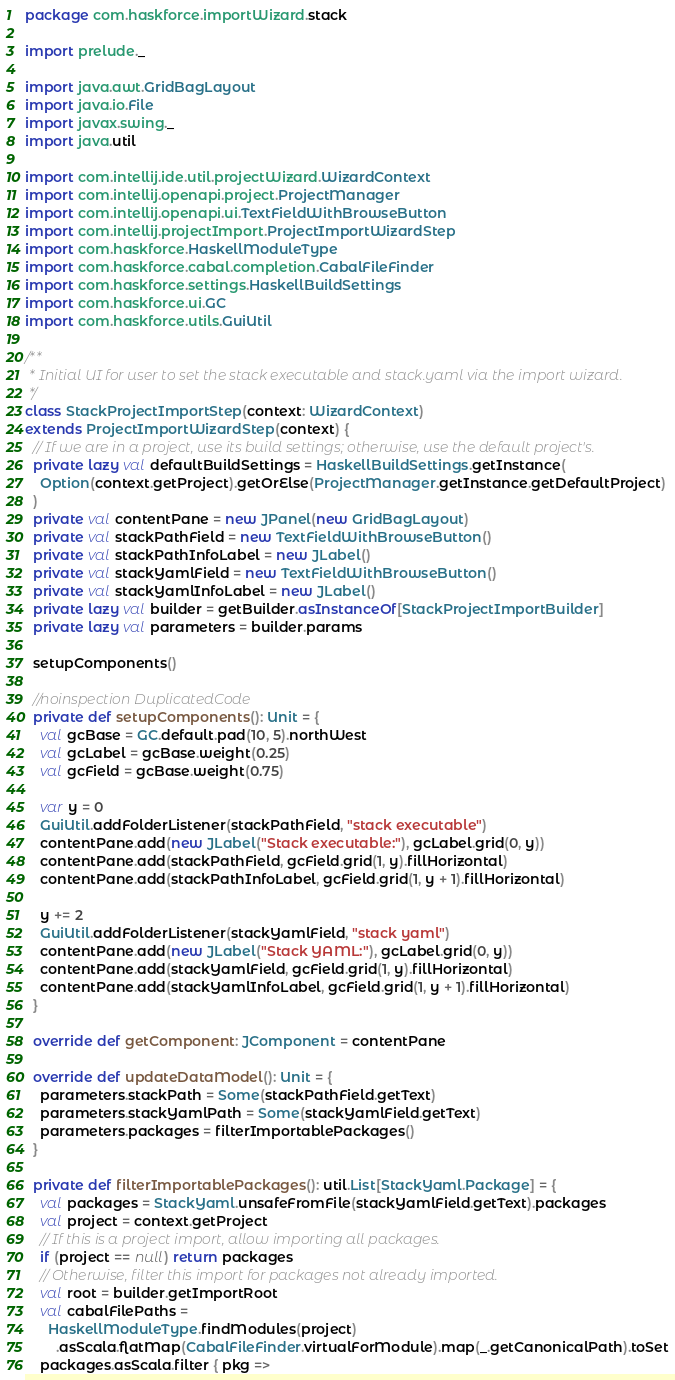<code> <loc_0><loc_0><loc_500><loc_500><_Scala_>package com.haskforce.importWizard.stack

import prelude._

import java.awt.GridBagLayout
import java.io.File
import javax.swing._
import java.util

import com.intellij.ide.util.projectWizard.WizardContext
import com.intellij.openapi.project.ProjectManager
import com.intellij.openapi.ui.TextFieldWithBrowseButton
import com.intellij.projectImport.ProjectImportWizardStep
import com.haskforce.HaskellModuleType
import com.haskforce.cabal.completion.CabalFileFinder
import com.haskforce.settings.HaskellBuildSettings
import com.haskforce.ui.GC
import com.haskforce.utils.GuiUtil

/**
 * Initial UI for user to set the stack executable and stack.yaml via the import wizard.
 */
class StackProjectImportStep(context: WizardContext)
extends ProjectImportWizardStep(context) {
  // If we are in a project, use its build settings; otherwise, use the default project's.
  private lazy val defaultBuildSettings = HaskellBuildSettings.getInstance(
    Option(context.getProject).getOrElse(ProjectManager.getInstance.getDefaultProject)
  )
  private val contentPane = new JPanel(new GridBagLayout)
  private val stackPathField = new TextFieldWithBrowseButton()
  private val stackPathInfoLabel = new JLabel()
  private val stackYamlField = new TextFieldWithBrowseButton()
  private val stackYamlInfoLabel = new JLabel()
  private lazy val builder = getBuilder.asInstanceOf[StackProjectImportBuilder]
  private lazy val parameters = builder.params

  setupComponents()

  //noinspection DuplicatedCode
  private def setupComponents(): Unit = {
    val gcBase = GC.default.pad(10, 5).northWest
    val gcLabel = gcBase.weight(0.25)
    val gcField = gcBase.weight(0.75)

    var y = 0
    GuiUtil.addFolderListener(stackPathField, "stack executable")
    contentPane.add(new JLabel("Stack executable:"), gcLabel.grid(0, y))
    contentPane.add(stackPathField, gcField.grid(1, y).fillHorizontal)
    contentPane.add(stackPathInfoLabel, gcField.grid(1, y + 1).fillHorizontal)

    y += 2
    GuiUtil.addFolderListener(stackYamlField, "stack yaml")
    contentPane.add(new JLabel("Stack YAML:"), gcLabel.grid(0, y))
    contentPane.add(stackYamlField, gcField.grid(1, y).fillHorizontal)
    contentPane.add(stackYamlInfoLabel, gcField.grid(1, y + 1).fillHorizontal)
  }

  override def getComponent: JComponent = contentPane

  override def updateDataModel(): Unit = {
    parameters.stackPath = Some(stackPathField.getText)
    parameters.stackYamlPath = Some(stackYamlField.getText)
    parameters.packages = filterImportablePackages()
  }

  private def filterImportablePackages(): util.List[StackYaml.Package] = {
    val packages = StackYaml.unsafeFromFile(stackYamlField.getText).packages
    val project = context.getProject
    // If this is a project import, allow importing all packages.
    if (project == null) return packages
    // Otherwise, filter this import for packages not already imported.
    val root = builder.getImportRoot
    val cabalFilePaths =
      HaskellModuleType.findModules(project)
        .asScala.flatMap(CabalFileFinder.virtualForModule).map(_.getCanonicalPath).toSet
    packages.asScala.filter { pkg =></code> 